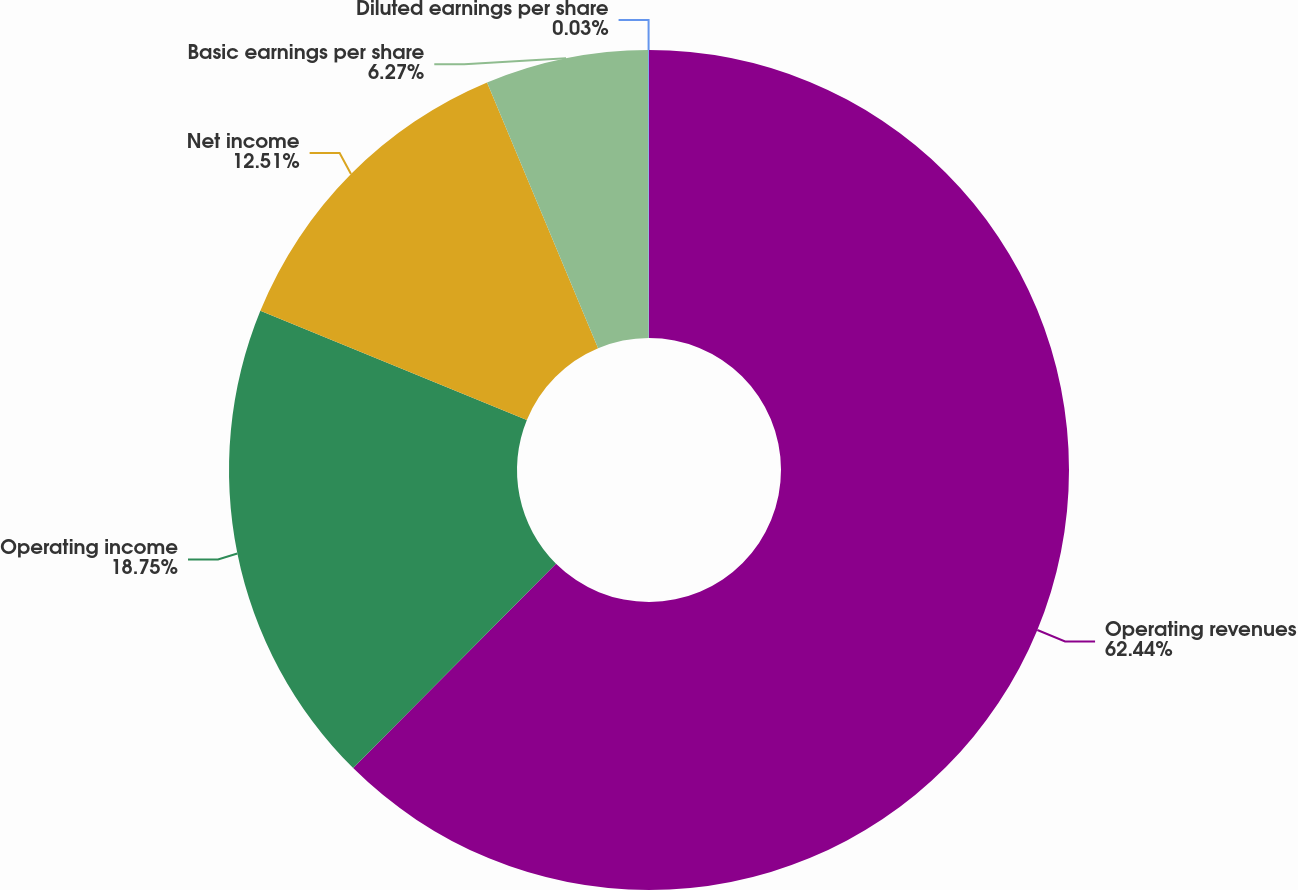<chart> <loc_0><loc_0><loc_500><loc_500><pie_chart><fcel>Operating revenues<fcel>Operating income<fcel>Net income<fcel>Basic earnings per share<fcel>Diluted earnings per share<nl><fcel>62.44%<fcel>18.75%<fcel>12.51%<fcel>6.27%<fcel>0.03%<nl></chart> 